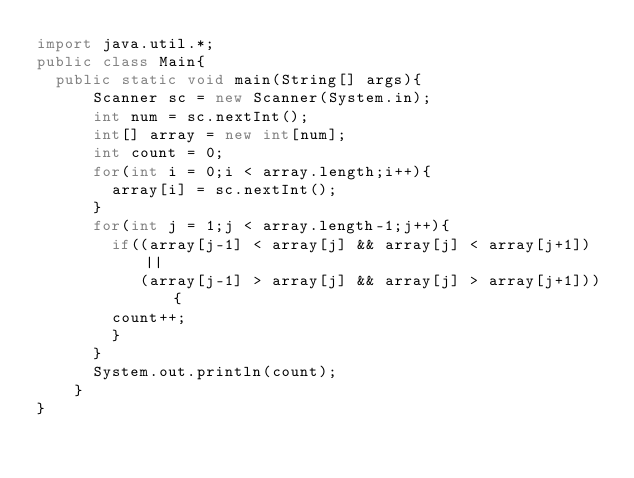Convert code to text. <code><loc_0><loc_0><loc_500><loc_500><_Java_>import java.util.*;
public class Main{
	public static void main(String[] args){
    	Scanner sc = new Scanner(System.in);
      int num = sc.nextInt();
      int[] array = new int[num];
      int count = 0;
      for(int i = 0;i < array.length;i++){
      	array[i] = sc.nextInt();
      }
      for(int j = 1;j < array.length-1;j++){
      	if((array[j-1] < array[j] && array[j] < array[j+1])||
           (array[j-1] > array[j] && array[j] > array[j+1])){
        count++;
        }
      }
      System.out.println(count);
    }
}
</code> 